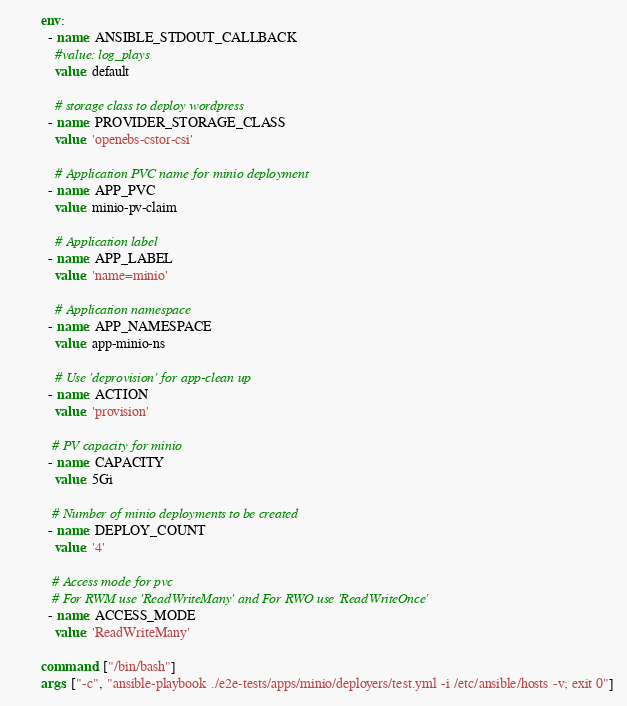Convert code to text. <code><loc_0><loc_0><loc_500><loc_500><_YAML_>        env:
          - name: ANSIBLE_STDOUT_CALLBACK
            #value: log_plays
            value: default

            # storage class to deploy wordpress
          - name: PROVIDER_STORAGE_CLASS
            value: 'openebs-cstor-csi'
     
            # Application PVC name for minio deployment
          - name: APP_PVC
            value: minio-pv-claim

            # Application label
          - name: APP_LABEL
            value: 'name=minio'

            # Application namespace
          - name: APP_NAMESPACE
            value: app-minio-ns 

            # Use 'deprovision' for app-clean up
          - name: ACTION
            value: 'provision'

           # PV capacity for minio  
          - name: CAPACITY
            value: 5Gi

           # Number of minio deployments to be created
          - name: DEPLOY_COUNT
            value: '4'
           
           # Access mode for pvc
           # For RWM use 'ReadWriteMany' and For RWO use 'ReadWriteOnce'
          - name: ACCESS_MODE
            value: 'ReadWriteMany'  

        command: ["/bin/bash"]
        args: ["-c", "ansible-playbook ./e2e-tests/apps/minio/deployers/test.yml -i /etc/ansible/hosts -v; exit 0"]
</code> 